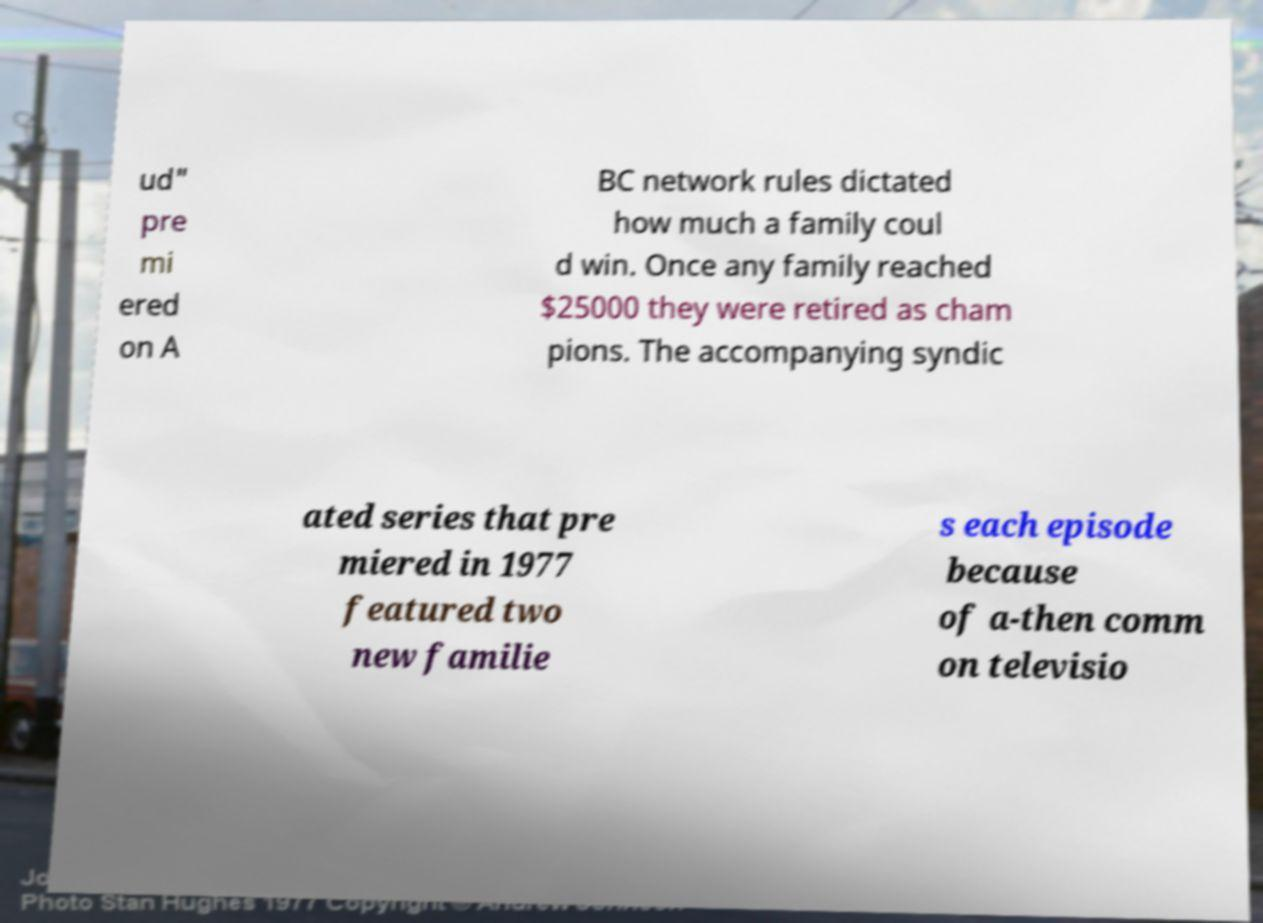Please identify and transcribe the text found in this image. ud" pre mi ered on A BC network rules dictated how much a family coul d win. Once any family reached $25000 they were retired as cham pions. The accompanying syndic ated series that pre miered in 1977 featured two new familie s each episode because of a-then comm on televisio 